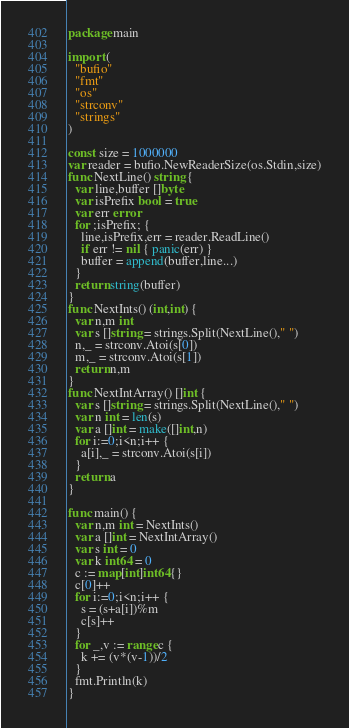Convert code to text. <code><loc_0><loc_0><loc_500><loc_500><_Go_>package main

import (
  "bufio"
  "fmt"
  "os"
  "strconv"
  "strings"
)

const size = 1000000
var reader = bufio.NewReaderSize(os.Stdin,size)
func NextLine() string {
  var line,buffer []byte
  var isPrefix bool = true
  var err error
  for ;isPrefix; {
    line,isPrefix,err = reader.ReadLine()
    if err != nil { panic(err) }
    buffer = append(buffer,line...)
  }
  return string(buffer)
}
func NextInts() (int,int) {
  var n,m int
  var s []string = strings.Split(NextLine()," ")
  n,_ = strconv.Atoi(s[0])
  m,_ = strconv.Atoi(s[1])
  return n,m
}
func NextIntArray() []int {
  var s []string = strings.Split(NextLine()," ")
  var n int = len(s)
  var a []int = make([]int,n)
  for i:=0;i<n;i++ {
    a[i],_ = strconv.Atoi(s[i])
  }
  return a
}

func main() {
  var n,m int = NextInts()
  var a []int = NextIntArray()
  var s int = 0
  var k int64 = 0
  c := map[int]int64{}
  c[0]++
  for i:=0;i<n;i++ {
    s = (s+a[i])%m
    c[s]++
  }
  for _,v := range c {
    k += (v*(v-1))/2
  }
  fmt.Println(k)
}</code> 